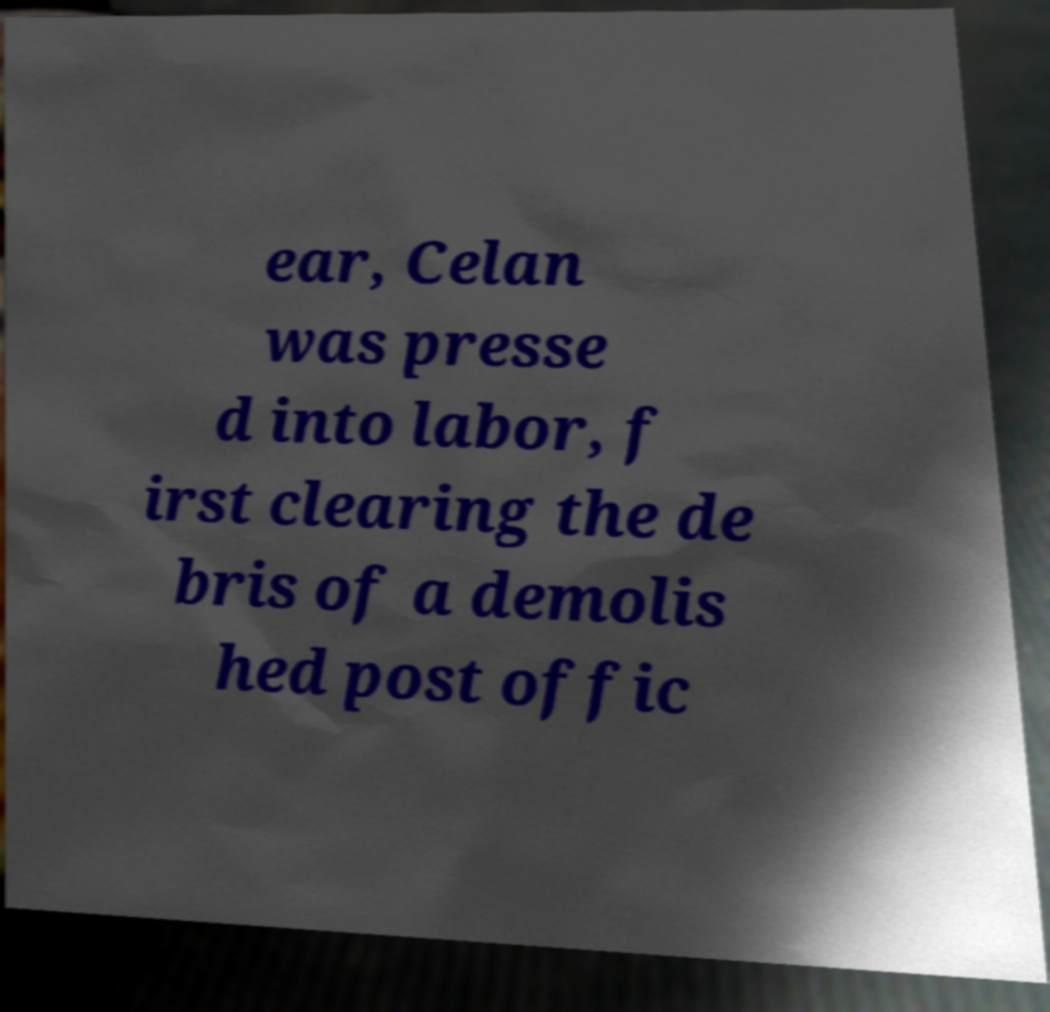Could you extract and type out the text from this image? ear, Celan was presse d into labor, f irst clearing the de bris of a demolis hed post offic 